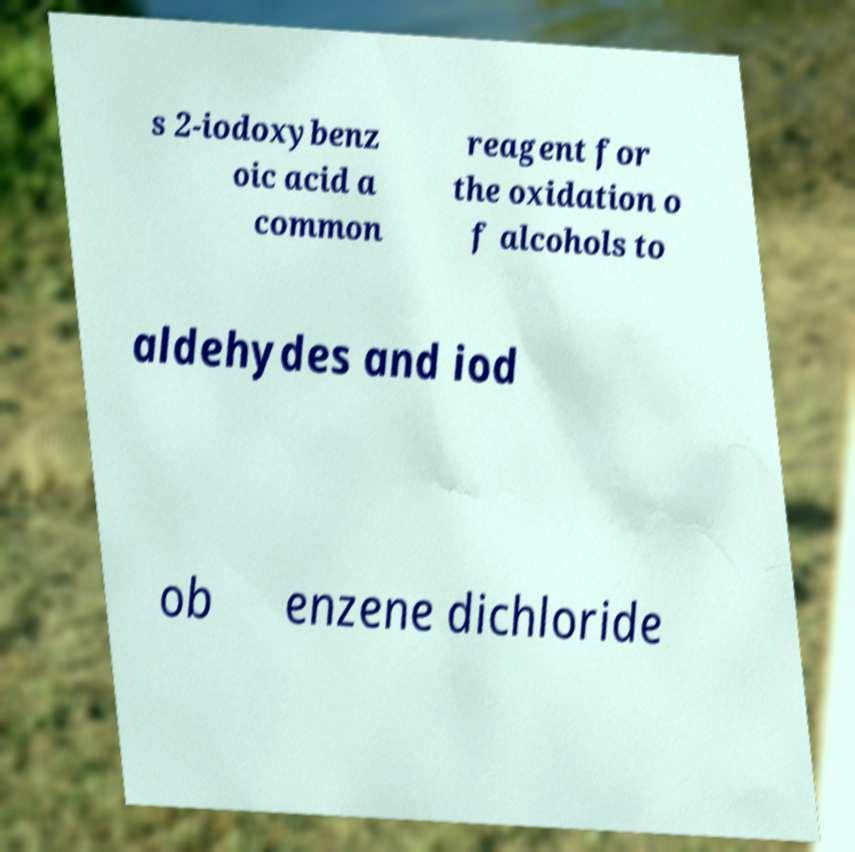Can you accurately transcribe the text from the provided image for me? s 2-iodoxybenz oic acid a common reagent for the oxidation o f alcohols to aldehydes and iod ob enzene dichloride 